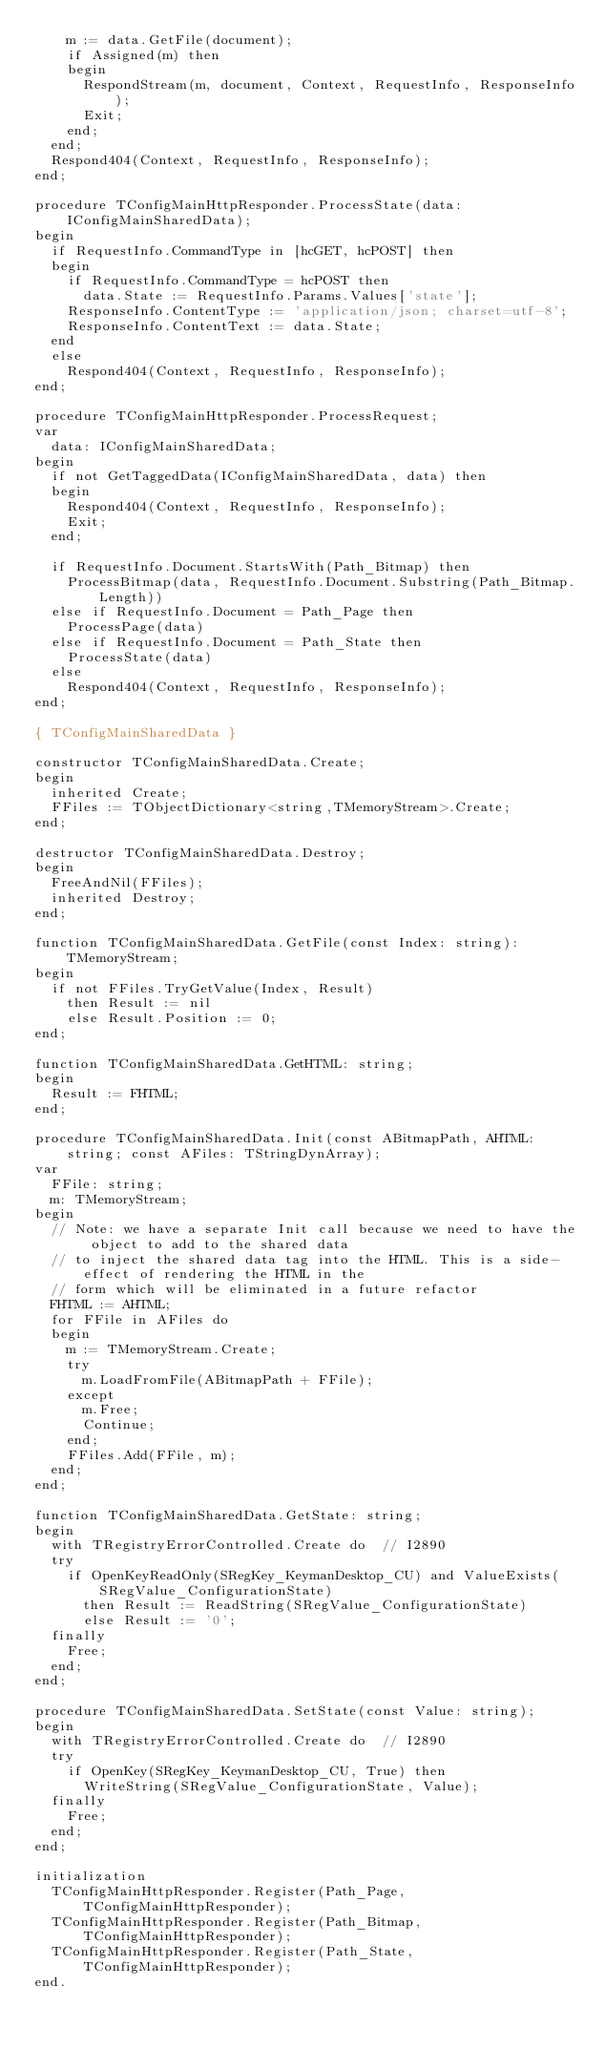Convert code to text. <code><loc_0><loc_0><loc_500><loc_500><_Pascal_>    m := data.GetFile(document);
    if Assigned(m) then
    begin
      RespondStream(m, document, Context, RequestInfo, ResponseInfo);
      Exit;
    end;
  end;
  Respond404(Context, RequestInfo, ResponseInfo);
end;

procedure TConfigMainHttpResponder.ProcessState(data: IConfigMainSharedData);
begin
  if RequestInfo.CommandType in [hcGET, hcPOST] then
  begin
    if RequestInfo.CommandType = hcPOST then
      data.State := RequestInfo.Params.Values['state'];
    ResponseInfo.ContentType := 'application/json; charset=utf-8';
    ResponseInfo.ContentText := data.State;
  end
  else
    Respond404(Context, RequestInfo, ResponseInfo);
end;

procedure TConfigMainHttpResponder.ProcessRequest;
var
  data: IConfigMainSharedData;
begin
  if not GetTaggedData(IConfigMainSharedData, data) then
  begin
    Respond404(Context, RequestInfo, ResponseInfo);
    Exit;
  end;

  if RequestInfo.Document.StartsWith(Path_Bitmap) then
    ProcessBitmap(data, RequestInfo.Document.Substring(Path_Bitmap.Length))
  else if RequestInfo.Document = Path_Page then
    ProcessPage(data)
  else if RequestInfo.Document = Path_State then
    ProcessState(data)
  else
    Respond404(Context, RequestInfo, ResponseInfo);
end;

{ TConfigMainSharedData }

constructor TConfigMainSharedData.Create;
begin
  inherited Create;
  FFiles := TObjectDictionary<string,TMemoryStream>.Create;
end;

destructor TConfigMainSharedData.Destroy;
begin
  FreeAndNil(FFiles);
  inherited Destroy;
end;

function TConfigMainSharedData.GetFile(const Index: string): TMemoryStream;
begin
  if not FFiles.TryGetValue(Index, Result)
    then Result := nil
    else Result.Position := 0;
end;

function TConfigMainSharedData.GetHTML: string;
begin
  Result := FHTML;
end;

procedure TConfigMainSharedData.Init(const ABitmapPath, AHTML: string; const AFiles: TStringDynArray);
var
  FFile: string;
  m: TMemoryStream;
begin
  // Note: we have a separate Init call because we need to have the object to add to the shared data
  // to inject the shared data tag into the HTML. This is a side-effect of rendering the HTML in the
  // form which will be eliminated in a future refactor
  FHTML := AHTML;
  for FFile in AFiles do
  begin
    m := TMemoryStream.Create;
    try
      m.LoadFromFile(ABitmapPath + FFile);
    except
      m.Free;
      Continue;
    end;
    FFiles.Add(FFile, m);
  end;
end;

function TConfigMainSharedData.GetState: string;
begin
  with TRegistryErrorControlled.Create do  // I2890
  try
    if OpenKeyReadOnly(SRegKey_KeymanDesktop_CU) and ValueExists(SRegValue_ConfigurationState)
      then Result := ReadString(SRegValue_ConfigurationState)
      else Result := '0';
  finally
    Free;
  end;
end;

procedure TConfigMainSharedData.SetState(const Value: string);
begin
  with TRegistryErrorControlled.Create do  // I2890
  try
    if OpenKey(SRegKey_KeymanDesktop_CU, True) then
      WriteString(SRegValue_ConfigurationState, Value);
  finally
    Free;
  end;
end;

initialization
  TConfigMainHttpResponder.Register(Path_Page, TConfigMainHttpResponder);
  TConfigMainHttpResponder.Register(Path_Bitmap, TConfigMainHttpResponder);
  TConfigMainHttpResponder.Register(Path_State, TConfigMainHttpResponder);
end.
</code> 